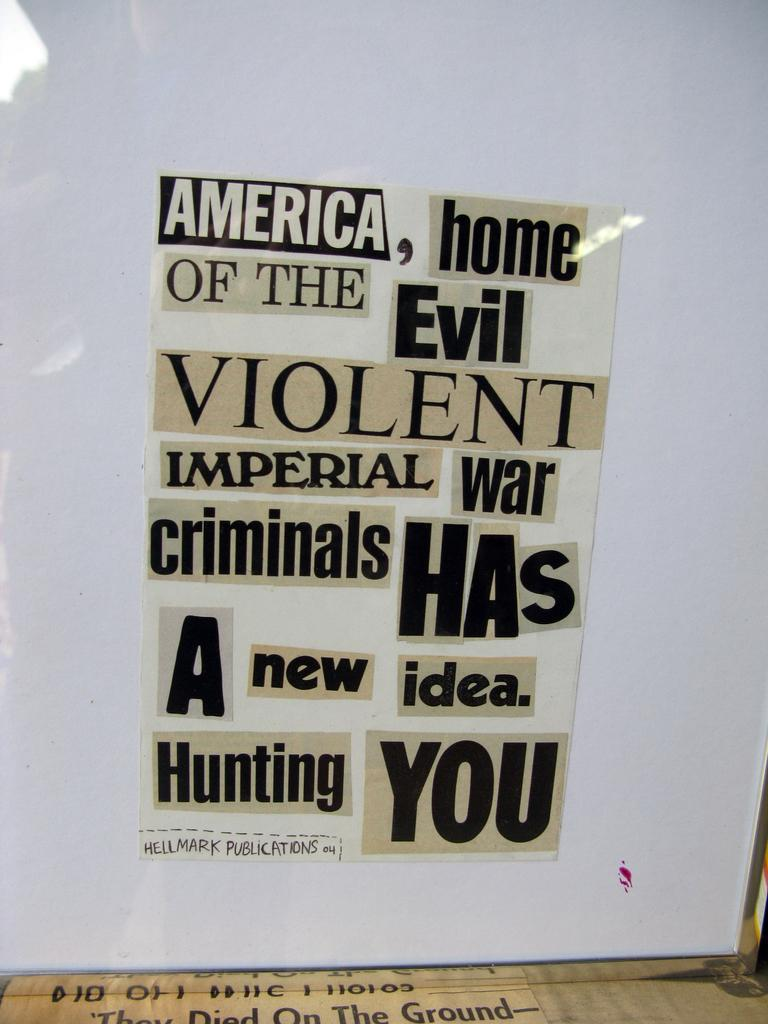<image>
Write a terse but informative summary of the picture. words cut from newspapers that say 'america, home of the evil violent imperial war criminals has a new idea. haunting you.' 